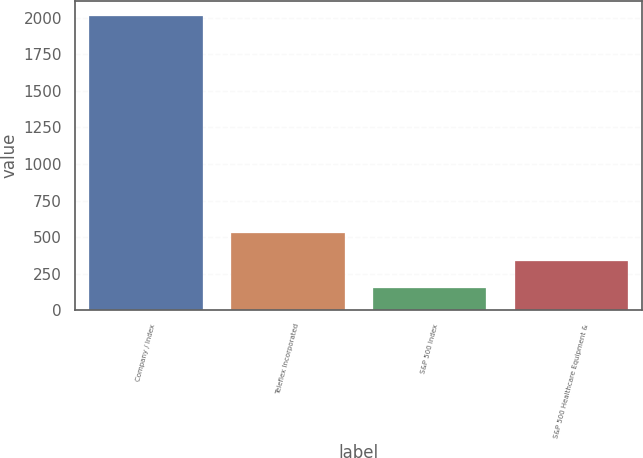Convert chart to OTSL. <chart><loc_0><loc_0><loc_500><loc_500><bar_chart><fcel>Company / Index<fcel>Teleflex Incorporated<fcel>S&P 500 Index<fcel>S&P 500 Healthcare Equipment &<nl><fcel>2015<fcel>525.4<fcel>153<fcel>339.2<nl></chart> 